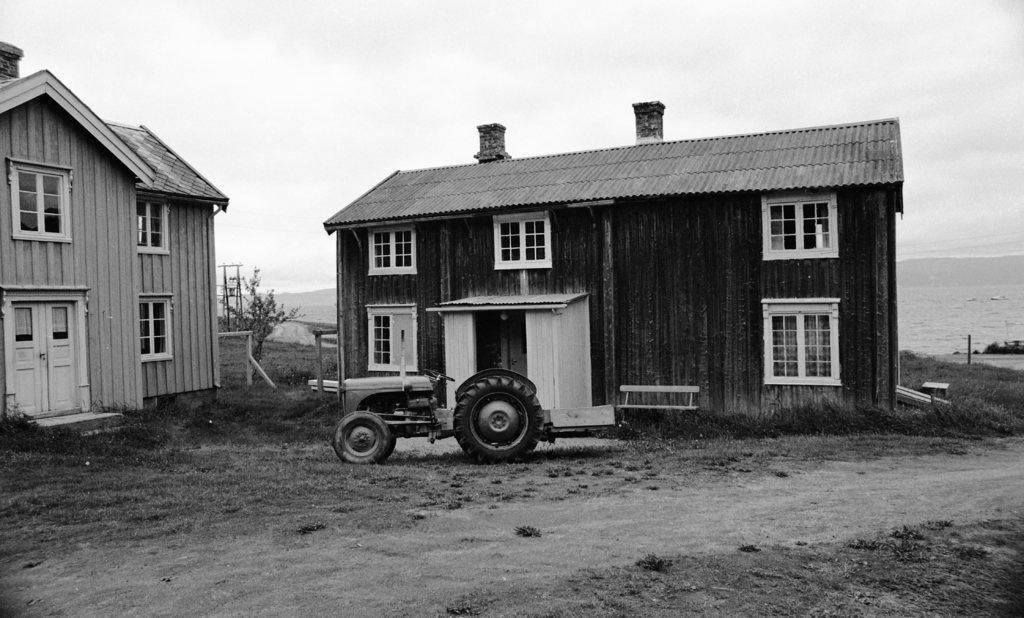Please provide a concise description of this image. This is a black and white image and here we can see sheds and there is a vehicle on the ground and we can see a bench, a tree and poles. In the background, there is water and we can see hills. At the top, there is sky. 